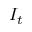Convert formula to latex. <formula><loc_0><loc_0><loc_500><loc_500>I _ { t }</formula> 